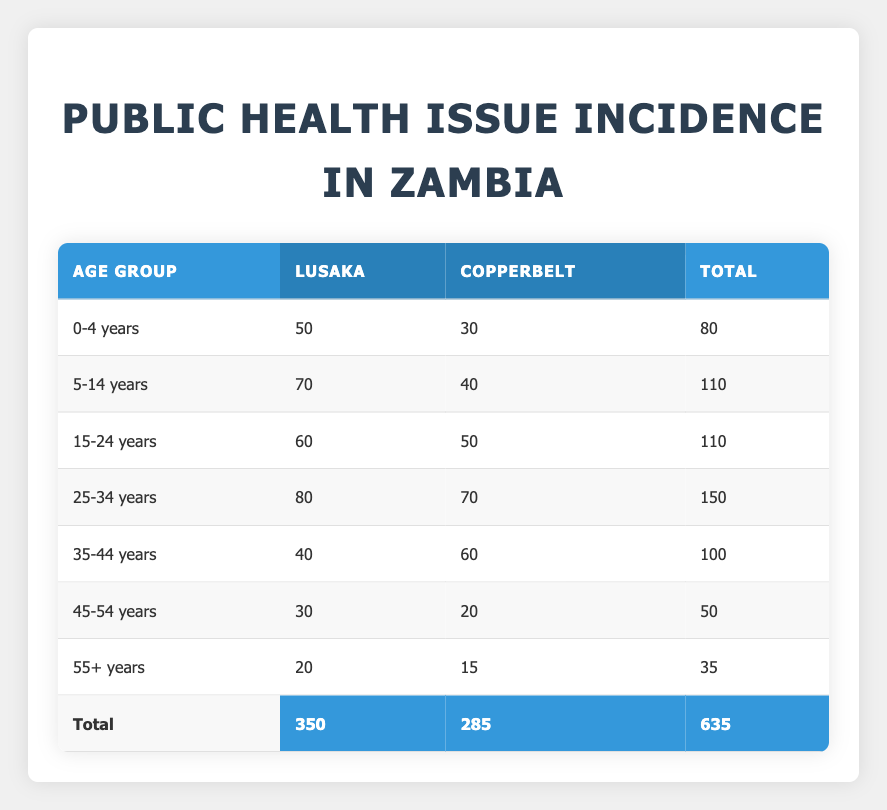What is the incidence of health issues in the age group 25-34 years in Lusaka? According to the table, the incidence of health issues for the age group 25-34 years in Lusaka is directly shown in the corresponding cell. The value is 80.
Answer: 80 Which locality has a higher incidence for the age group 15-24 years? The incidences for the age group 15-24 years are compared between Lusaka and Copperbelt. Lusaka has an incidence of 60 while Copperbelt has 50. Therefore, Lusaka has a higher incidence.
Answer: Lusaka What is the total incidence of health issues for individuals aged 0-4 years? The table provides the specific incidences for the age group 0-4 years in both Lusaka and Copperbelt, which are 50 and 30 respectively. Adding these yields a total incidence of 50 + 30 = 80.
Answer: 80 Is the incidence of health issues for people aged 55+ years higher in Lusaka than in Copperbelt? The table shows an incidence of 20 for Lusaka and 15 for Copperbelt in the age group 55+ years. Since 20 is greater than 15, the answer is yes.
Answer: Yes What is the difference in incidence of health issues between the age groups 5-14 years and 25-34 years in Copperbelt? First, we look at the incidences for both age groups: 5-14 years has 40 cases and 25-34 years has 70 cases in Copperbelt. The difference is calculated as 70 - 40 = 30.
Answer: 30 What is the total incidence of health issues across all localities and age groups? To find the total incidence, we sum the values in the total column: 80 + 110 + 110 + 150 + 100 + 50 + 35. This equals 635. This sum shows the overall public health issue incidence across all groups and areas.
Answer: 635 Which age group has the lowest incidence of health issues in Lusaka? By reviewing the incidences for Lusaka: 50 (0-4), 70 (5-14), 60 (15-24), 80 (25-34), 40 (35-44), 30 (45-54), 20 (55+), we see that 20 is the smallest value, which corresponds to the age group 55+.
Answer: 55+ years Is the total incidence of health issues in Copperbelt higher than in Lusaka? We can sum the total incidences for each locality: Lusaka has a total of 350, while Copperbelt has 285. Since 285 is less than 350, it is false that Copperbelt is higher.
Answer: No What is the average incidence of health issues per age group in Lusaka? To compute the average for Lusaka, we first find the total incidence, which is 350 from the table. There are 7 age groups listed, so the average is calculated as 350 divided by 7, resulting in approximately 50.
Answer: 50 